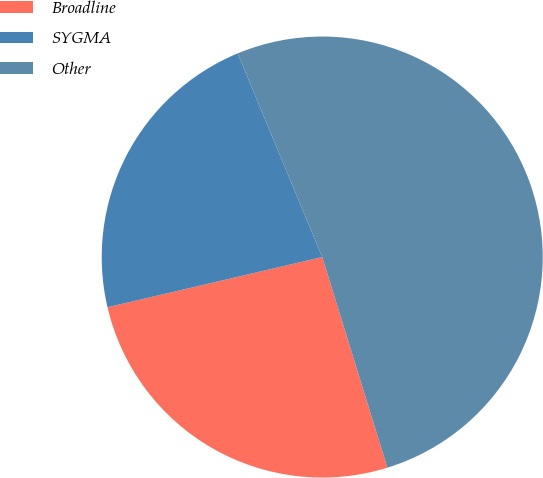<chart> <loc_0><loc_0><loc_500><loc_500><pie_chart><fcel>Broadline<fcel>SYGMA<fcel>Other<nl><fcel>26.12%<fcel>22.39%<fcel>51.49%<nl></chart> 